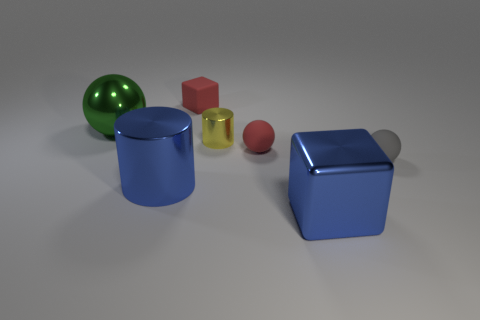Subtract all large green balls. How many balls are left? 2 Add 2 tiny red shiny spheres. How many objects exist? 9 Subtract all blue blocks. How many blocks are left? 1 Subtract all cylinders. How many objects are left? 5 Subtract 1 cubes. How many cubes are left? 1 Subtract 0 cyan cylinders. How many objects are left? 7 Subtract all purple cubes. Subtract all blue cylinders. How many cubes are left? 2 Subtract all cyan cylinders. How many blue cubes are left? 1 Subtract all tiny things. Subtract all cylinders. How many objects are left? 1 Add 1 big blue cubes. How many big blue cubes are left? 2 